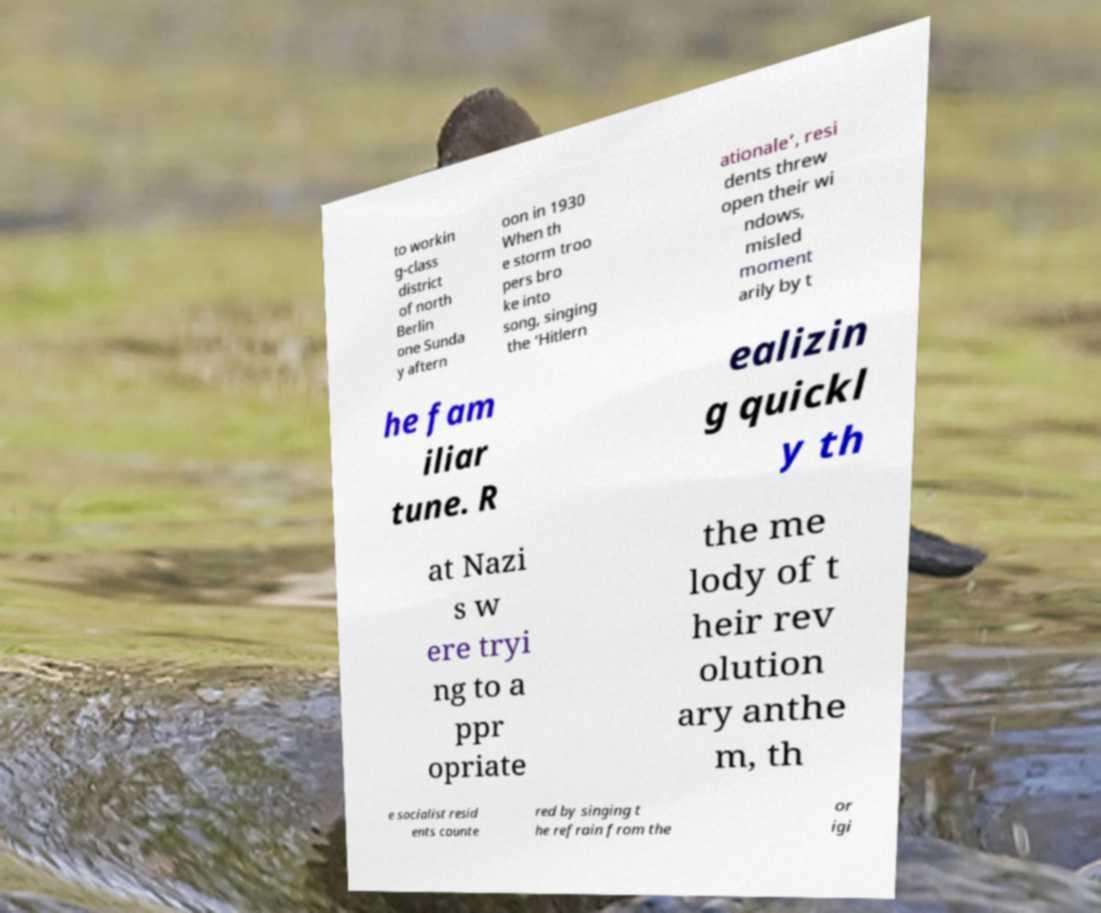Can you read and provide the text displayed in the image?This photo seems to have some interesting text. Can you extract and type it out for me? to workin g-class district of north Berlin one Sunda y aftern oon in 1930 When th e storm troo pers bro ke into song, singing the ‘Hitlern ationale’, resi dents threw open their wi ndows, misled moment arily by t he fam iliar tune. R ealizin g quickl y th at Nazi s w ere tryi ng to a ppr opriate the me lody of t heir rev olution ary anthe m, th e socialist resid ents counte red by singing t he refrain from the or igi 